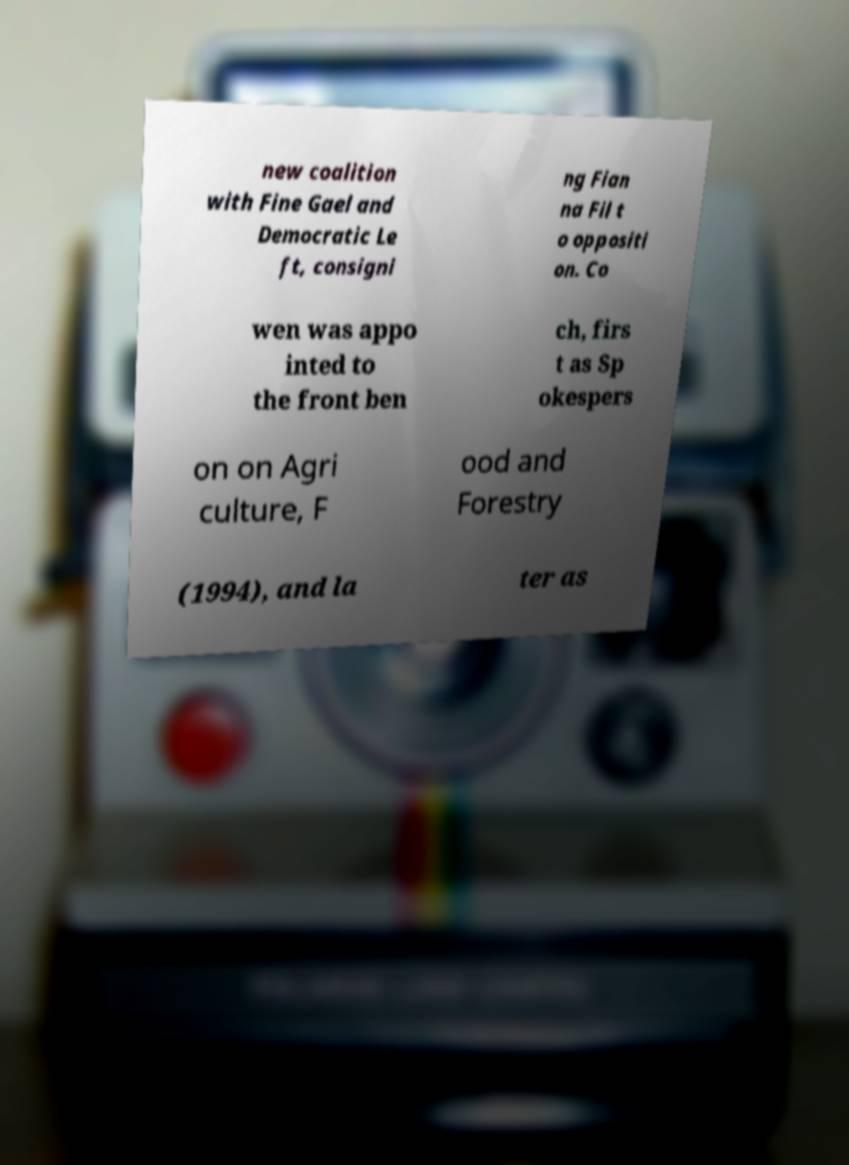For documentation purposes, I need the text within this image transcribed. Could you provide that? new coalition with Fine Gael and Democratic Le ft, consigni ng Fian na Fil t o oppositi on. Co wen was appo inted to the front ben ch, firs t as Sp okespers on on Agri culture, F ood and Forestry (1994), and la ter as 